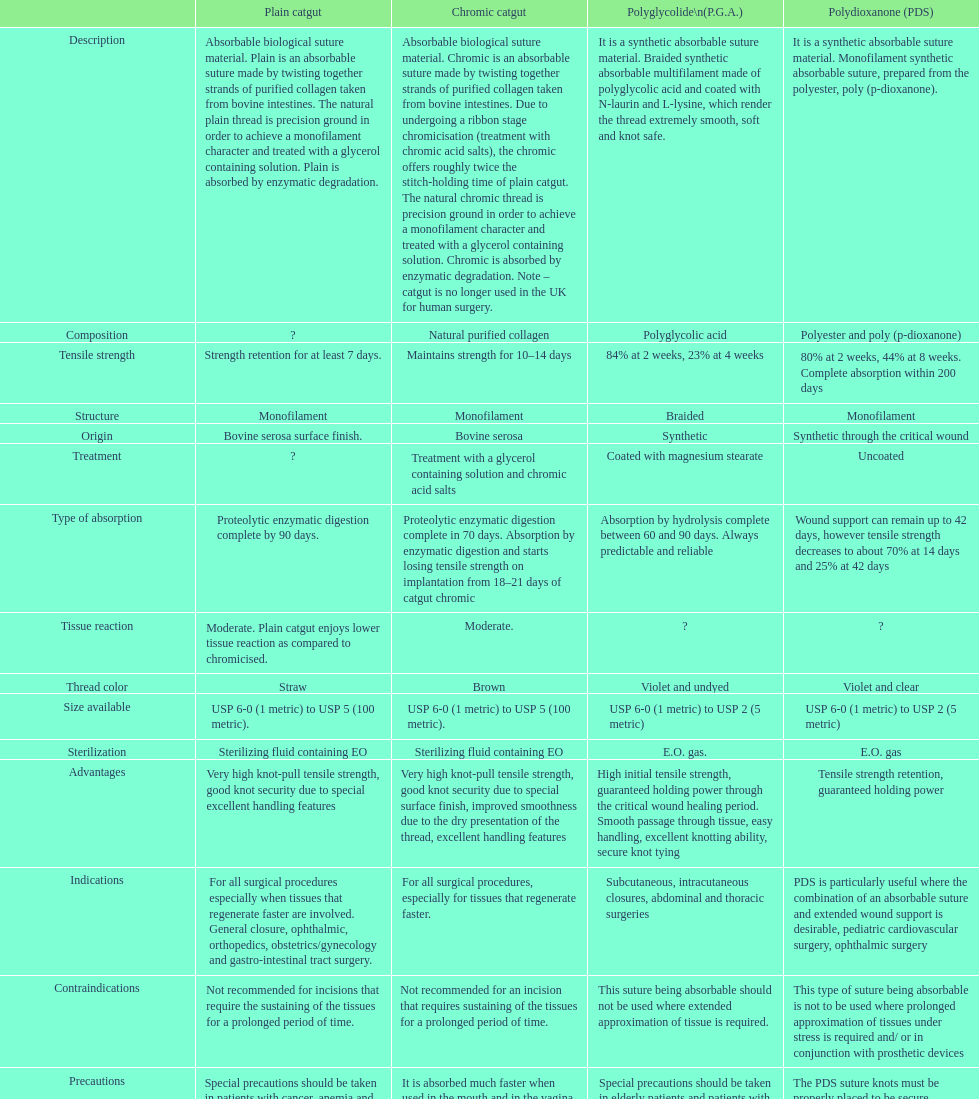What is the configuration besides monofilament? Braided. 